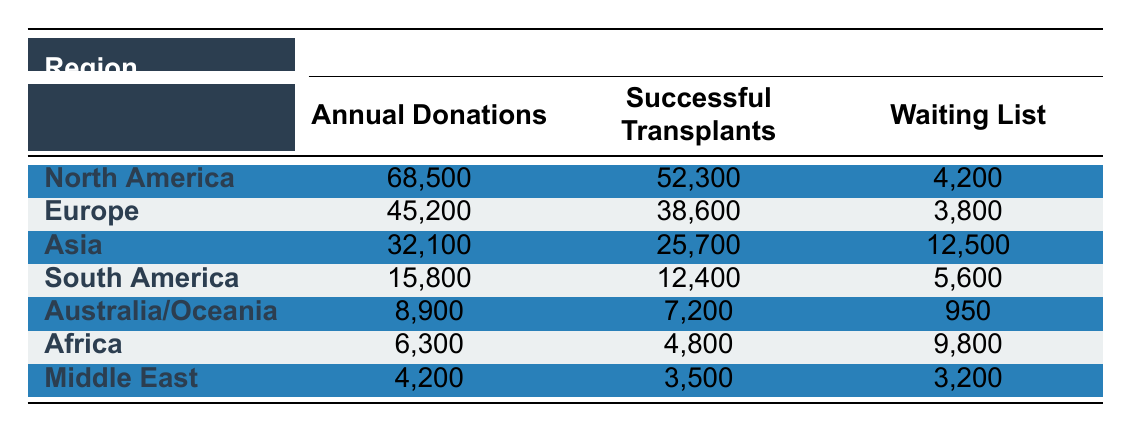What region has the most annual corneal donations? According to the table, North America has the highest number of annual corneal donations at 68,500.
Answer: North America What is the total number of successful transplants in Europe and South America combined? To find the total, we add the successful transplants from Europe (38,600) and South America (12,400). Thus, 38,600 + 12,400 = 51,000 successful transplants.
Answer: 51,000 Is the waiting list for corneal transplants in Asia greater than the combined waiting lists of Australia/Oceania and the Middle East? The waiting list in Asia is 12,500. The waiting lists in Australia/Oceania (950) and the Middle East (3,200) combine to 950 + 3,200 = 4,150. Since 12,500 is greater than 4,150, the statement is true.
Answer: Yes What percentage of annual donations in North America resulted in successful transplants? To find this percentage, we divide the successful transplants in North America (52,300) by the annual donations (68,500) and multiply by 100. The calculation is (52,300 / 68,500) × 100 = approximately 76.4%.
Answer: 76.4% Which region has the smallest number of annual corneal donations? By reviewing the table, we see that Africa has the smallest number of annual corneal donations at 6,300.
Answer: Africa What is the average number of successful transplants across all regions? To find the average, we first sum all successful transplants: 52,300 + 38,600 + 25,700 + 12,400 + 7,200 + 4,800 + 3,500 = 144,500. There are 7 regions, so the average is 144,500 / 7 = approximately 20,643.
Answer: 20,643 Did North America have more successful transplants than Asia, combined with South America? The successful transplants in Asia (25,700) and South America (12,400) total 25,700 + 12,400 = 38,100. North America had 52,300 successful transplants, which is greater than 38,100. Therefore, the statement is true.
Answer: Yes What is the difference in annual corneal donations between Europe and Africa? To find this difference, subtract the annual donations in Africa (6,300) from Europe (45,200). The difference is 45,200 - 6,300 = 38,900.
Answer: 38,900 